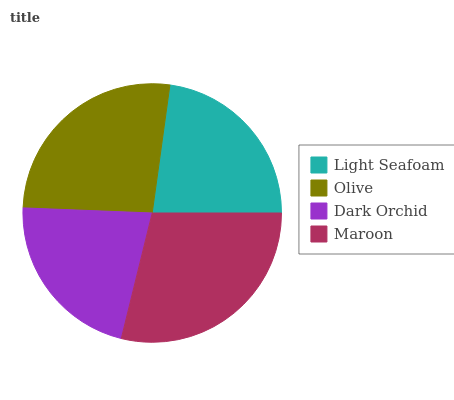Is Dark Orchid the minimum?
Answer yes or no. Yes. Is Maroon the maximum?
Answer yes or no. Yes. Is Olive the minimum?
Answer yes or no. No. Is Olive the maximum?
Answer yes or no. No. Is Olive greater than Light Seafoam?
Answer yes or no. Yes. Is Light Seafoam less than Olive?
Answer yes or no. Yes. Is Light Seafoam greater than Olive?
Answer yes or no. No. Is Olive less than Light Seafoam?
Answer yes or no. No. Is Olive the high median?
Answer yes or no. Yes. Is Light Seafoam the low median?
Answer yes or no. Yes. Is Maroon the high median?
Answer yes or no. No. Is Dark Orchid the low median?
Answer yes or no. No. 